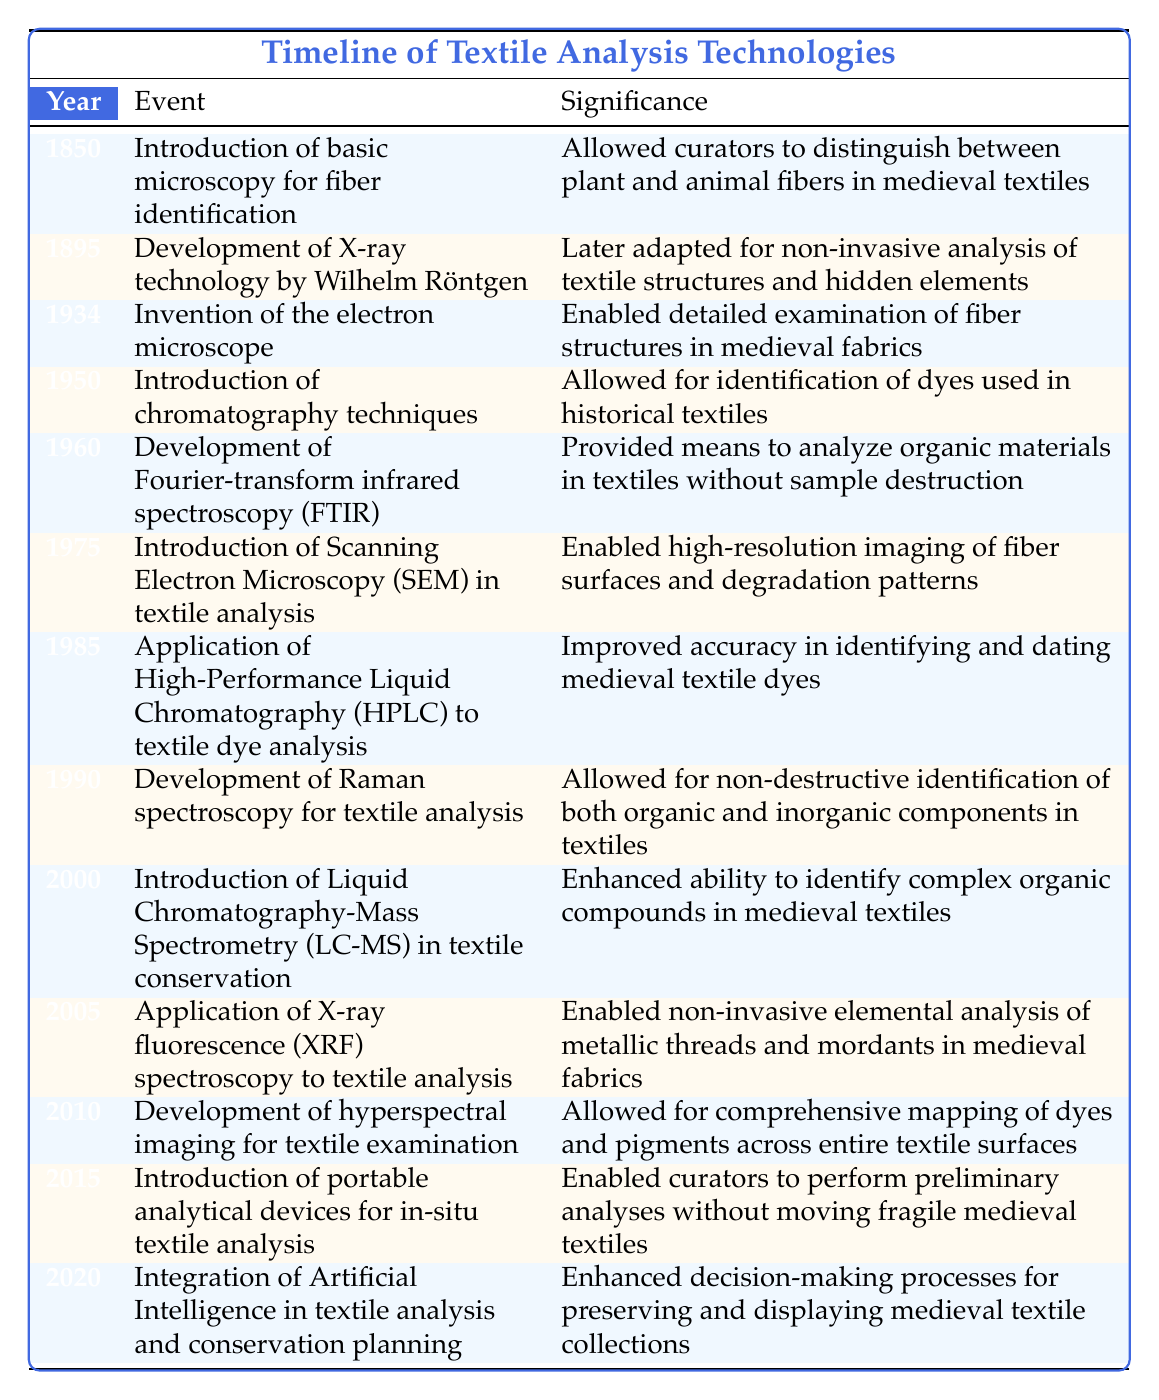What technology was introduced in 1850 for fiber identification? The table lists the event for the year 1850 as "Introduction of basic microscopy for fiber identification." Therefore, the technology introduced is microscopy.
Answer: Microscopy How did the development of X-ray technology in 1895 impact textile analysis? According to the table, X-ray technology was later adapted for non-invasive analysis of textile structures and hidden elements. This means it allowed curators to study textiles without causing damage.
Answer: Non-invasive analysis of textile structures What year did the introduction of portable analytical devices for in-situ textile analysis occur? By checking the table, the event related to portable analytical devices is listed in the year 2015.
Answer: 2015 Which technology allows non-destructive identification of components in textiles? The table indicates that Raman spectroscopy, developed in 1990, allows for non-destructive identification of both organic and inorganic components in textiles.
Answer: Raman spectroscopy Was electron microscopy invented before or after 1950? The table shows the invention of the electron microscope in 1934, which is before 1950. Thus, the answer is before.
Answer: Before What is the average year of significant technological advancements listed in the timeline? To find the average year, we add the years (1850, 1895, 1934, 1950, 1960, 1975, 1985, 1990, 2000, 2005, 2010, 2015, 2020) which sum up to 24,515. There are 13 events, so the average is 24,515 / 13 ≈ 1885.
Answer: 1885 Did the introduction of chromatography techniques occur in the 1950s? Yes, the table states that chromatography techniques were introduced in 1950, confirming that it occurred during the 1950s.
Answer: Yes What were the two advancements in textile analysis technologies introduced in the 2000s? Referring to the table, the two advancements introduced in the 2000s are Liquid Chromatography-Mass Spectrometry in 2000 and X-ray fluorescence spectroscopy in 2005.
Answer: LC-MS and XRF How did the introduction of Artificial Intelligence in 2020 enhance textile conservation? The table notes that the integration of Artificial Intelligence enhanced decision-making processes for preserving and displaying medieval textile collections, indicating a significant impact on conservation planning.
Answer: Enhanced decision-making processes 